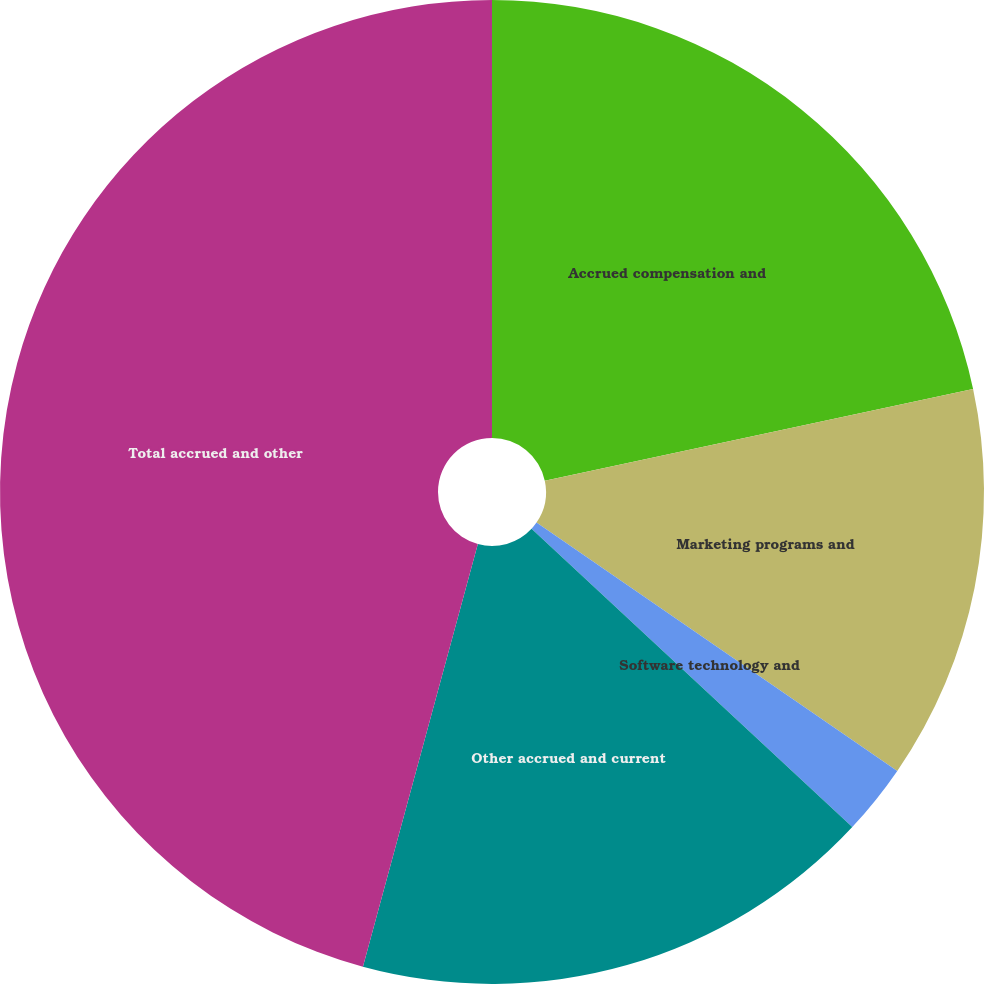Convert chart. <chart><loc_0><loc_0><loc_500><loc_500><pie_chart><fcel>Accrued compensation and<fcel>Marketing programs and<fcel>Software technology and<fcel>Other accrued and current<fcel>Total accrued and other<nl><fcel>21.64%<fcel>12.95%<fcel>2.33%<fcel>17.3%<fcel>45.77%<nl></chart> 